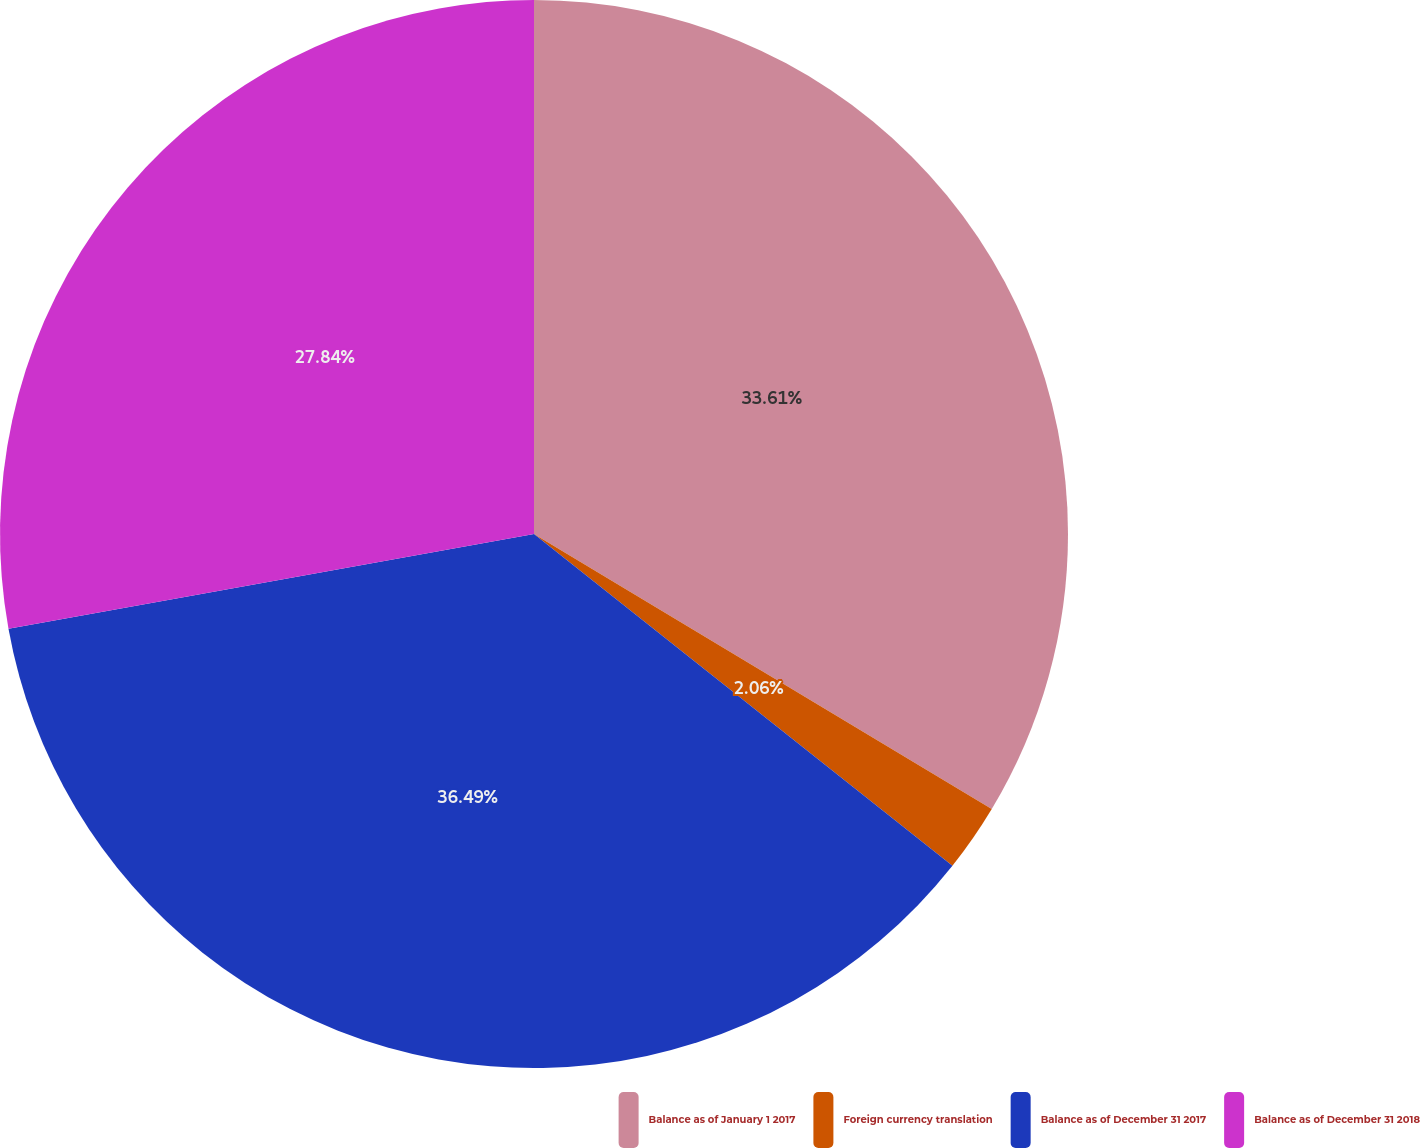<chart> <loc_0><loc_0><loc_500><loc_500><pie_chart><fcel>Balance as of January 1 2017<fcel>Foreign currency translation<fcel>Balance as of December 31 2017<fcel>Balance as of December 31 2018<nl><fcel>33.61%<fcel>2.06%<fcel>36.49%<fcel>27.84%<nl></chart> 